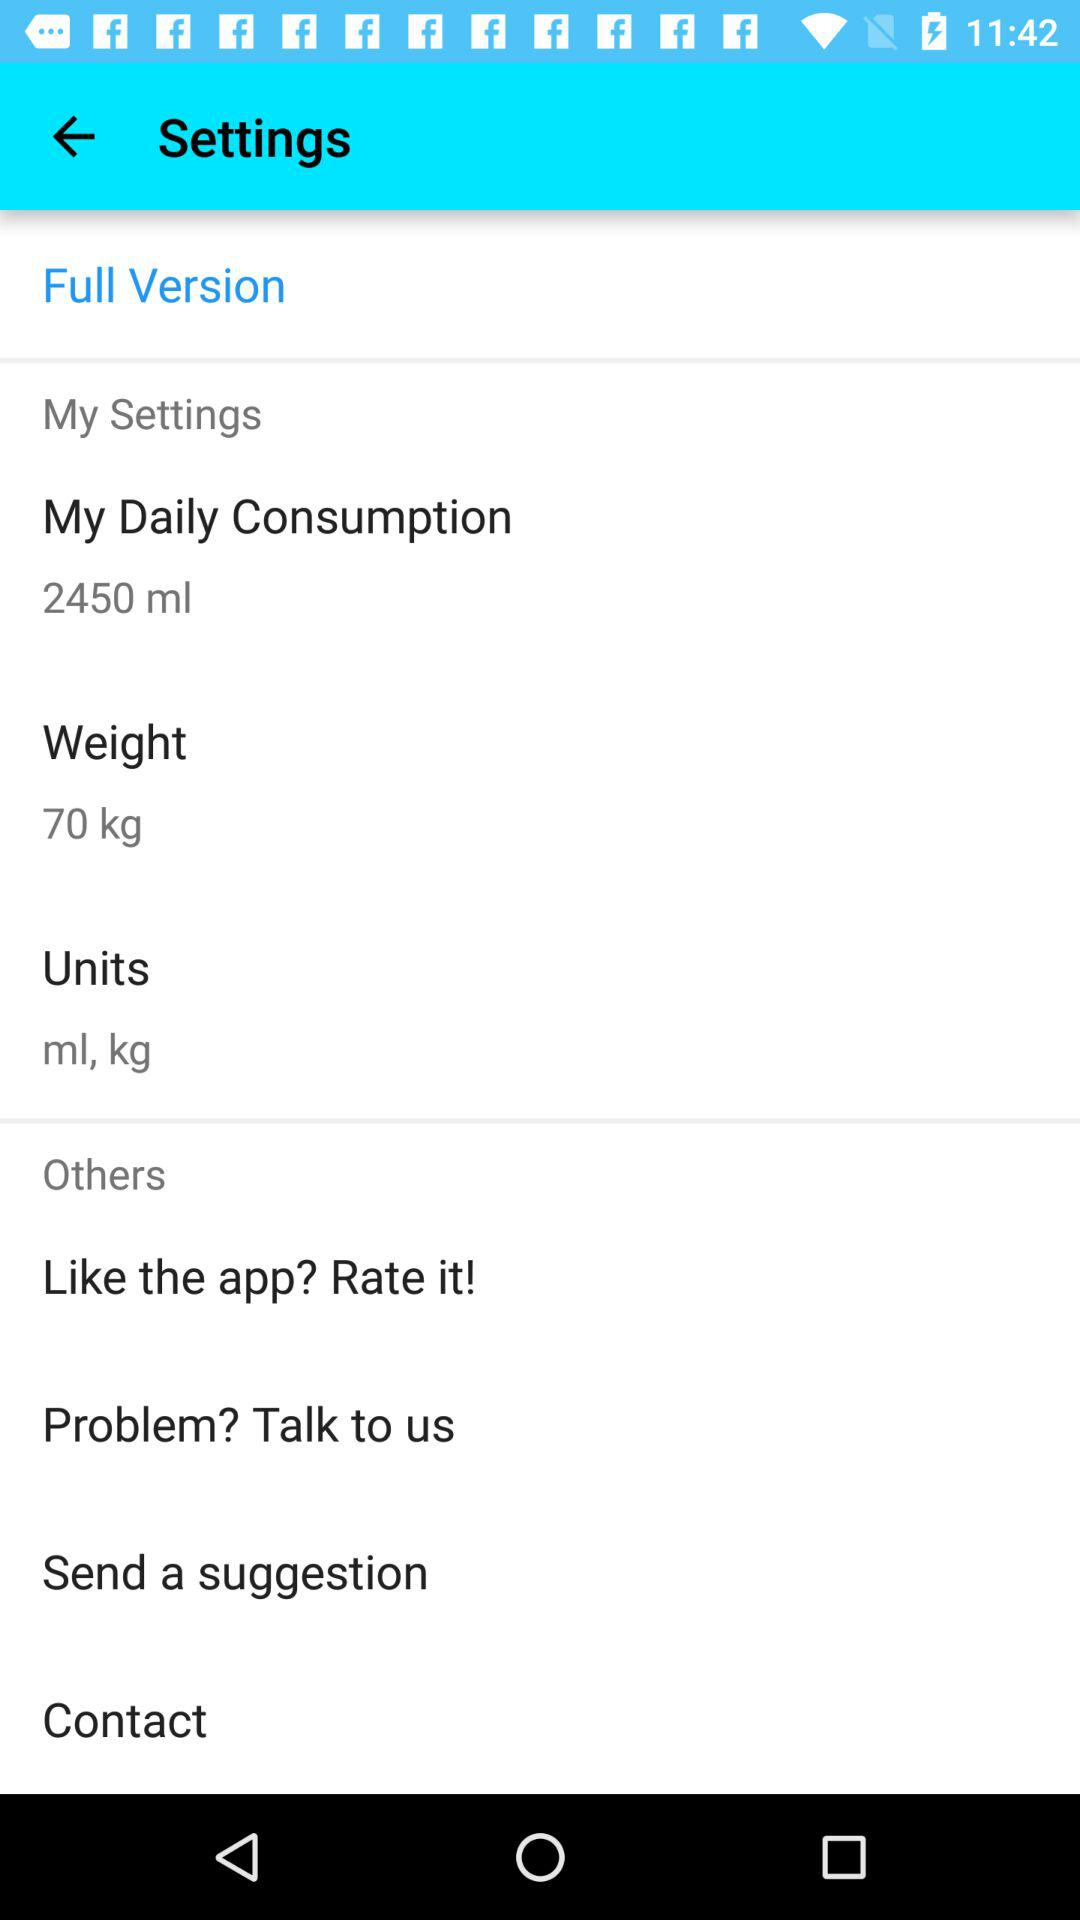What is the mentioned unit? The mentioned units are ml and kg. 